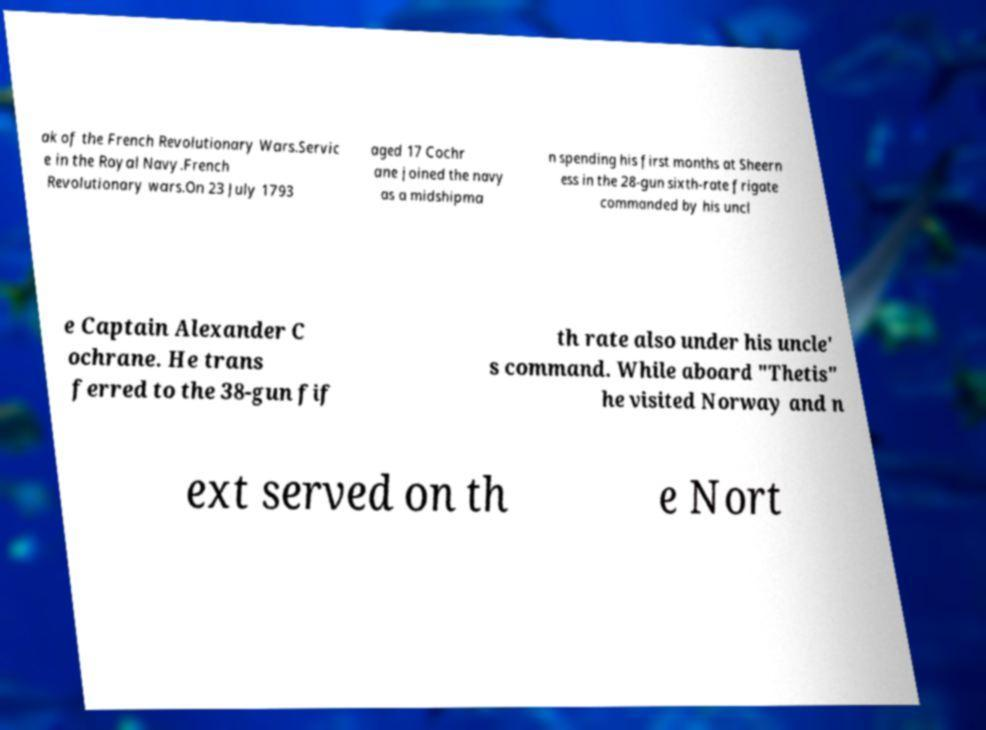For documentation purposes, I need the text within this image transcribed. Could you provide that? ak of the French Revolutionary Wars.Servic e in the Royal Navy.French Revolutionary wars.On 23 July 1793 aged 17 Cochr ane joined the navy as a midshipma n spending his first months at Sheern ess in the 28-gun sixth-rate frigate commanded by his uncl e Captain Alexander C ochrane. He trans ferred to the 38-gun fif th rate also under his uncle' s command. While aboard "Thetis" he visited Norway and n ext served on th e Nort 